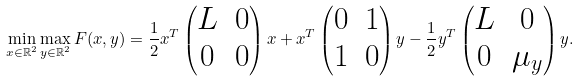<formula> <loc_0><loc_0><loc_500><loc_500>\min _ { x \in \mathbb { R } ^ { 2 } } \max _ { y \in \mathbb { R } ^ { 2 } } F ( x , y ) = \frac { 1 } { 2 } x ^ { T } \begin{pmatrix} L & 0 \\ 0 & 0 \end{pmatrix} x + x ^ { T } \begin{pmatrix} 0 & 1 \\ 1 & 0 \end{pmatrix} y - \frac { 1 } { 2 } y ^ { T } \begin{pmatrix} L & 0 \\ 0 & \mu _ { y } \end{pmatrix} y .</formula> 